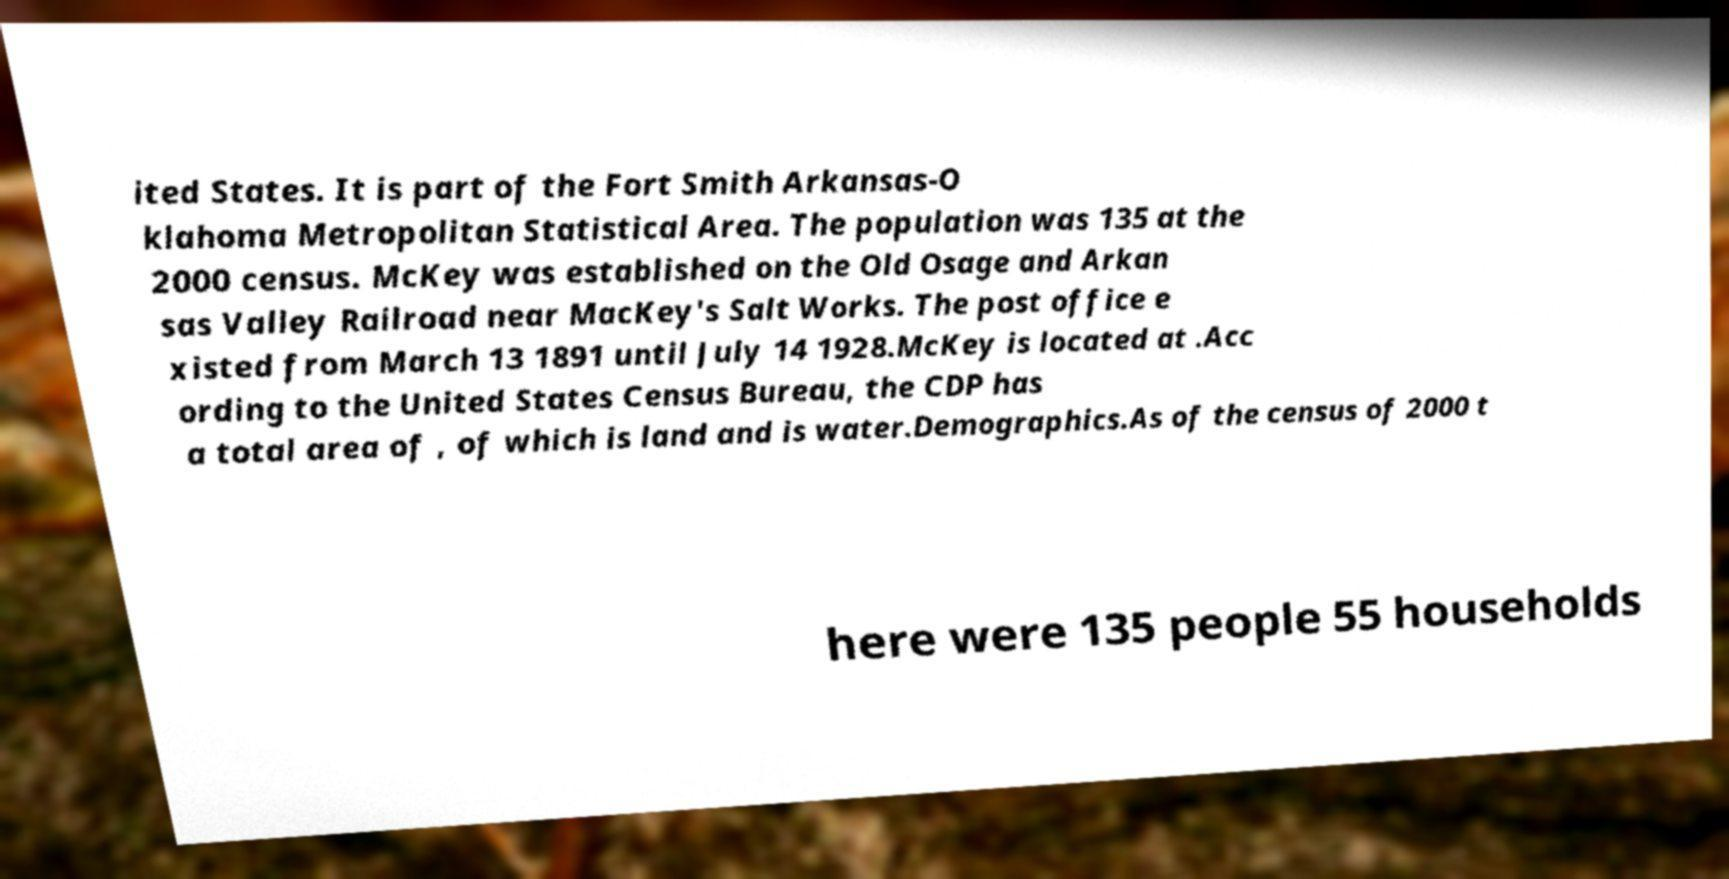For documentation purposes, I need the text within this image transcribed. Could you provide that? ited States. It is part of the Fort Smith Arkansas-O klahoma Metropolitan Statistical Area. The population was 135 at the 2000 census. McKey was established on the Old Osage and Arkan sas Valley Railroad near MacKey's Salt Works. The post office e xisted from March 13 1891 until July 14 1928.McKey is located at .Acc ording to the United States Census Bureau, the CDP has a total area of , of which is land and is water.Demographics.As of the census of 2000 t here were 135 people 55 households 